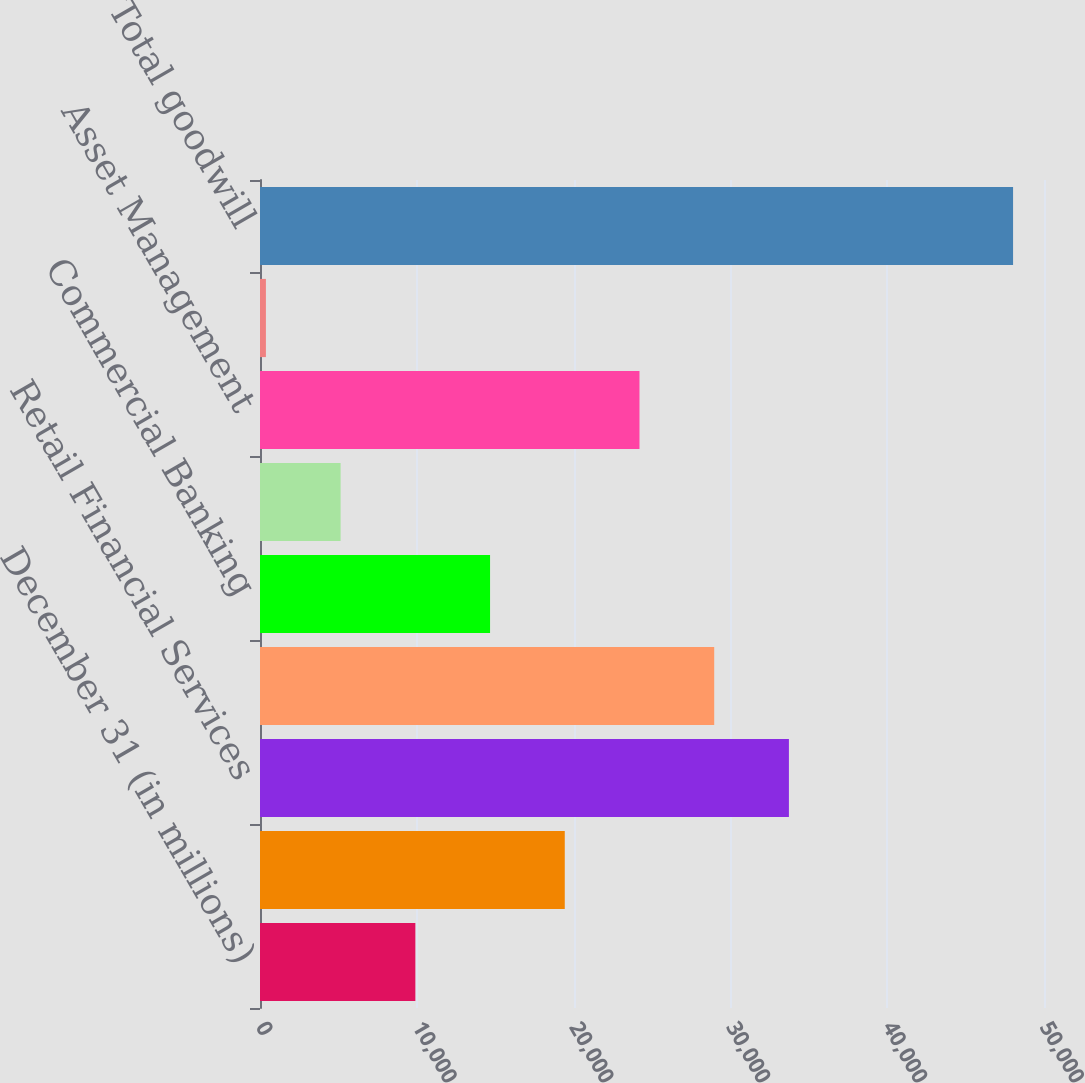Convert chart. <chart><loc_0><loc_0><loc_500><loc_500><bar_chart><fcel>December 31 (in millions)<fcel>Investment Bank<fcel>Retail Financial Services<fcel>Card Services<fcel>Commercial Banking<fcel>Treasury & Securities Services<fcel>Asset Management<fcel>Corporate/Private Equity<fcel>Total goodwill<nl><fcel>9907<fcel>19437<fcel>33732<fcel>28967<fcel>14672<fcel>5142<fcel>24202<fcel>377<fcel>48027<nl></chart> 